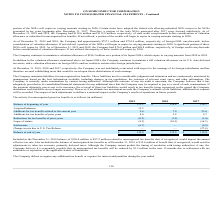According to On Semiconductor's financial document, How much was accrued interest and penalties at December 31, 2019? Based on the financial document, the answer is $5.1 million. Also, How much was accrued interest and penalties at December 31, 2018? Based on the financial document, the answer is $5.1 million. Also, How much was accrued interest and penalties at December 31, 2017? Based on the financial document, the answer is $5.9 million. Also, can you calculate: What is the change in Additions for tax benefits related to the current year from December 31, 2018 to 2019? Based on the calculation: 9.4-7.4, the result is 2 (in millions). This is based on the information: "for tax benefits related to the current year 9.4 7.4 23.6 ions for tax benefits related to the current year 9.4 7.4 23.6..." The key data points involved are: 7.4, 9.4. Also, can you calculate: What is the change in Lapse of statute from year ended December 31, 2018 to 2019? Based on the calculation: -8.2-(10.9), the result is 2.7 (in millions). This is based on the information: "Lapse of statute (8.2) (10.9) (16.3) Lapse of statute (8.2) (10.9) (16.3)..." The key data points involved are: 10.9, 8.2. Also, can you calculate: What is the average Additions for tax benefits related to the current year for December 31, 2018 and 2019? To answer this question, I need to perform calculations using the financial data. The calculation is: (9.4+7.4) / 2, which equals 8.4 (in millions). This is based on the information: "for tax benefits related to the current year 9.4 7.4 23.6 ions for tax benefits related to the current year 9.4 7.4 23.6..." The key data points involved are: 7.4, 9.4. 